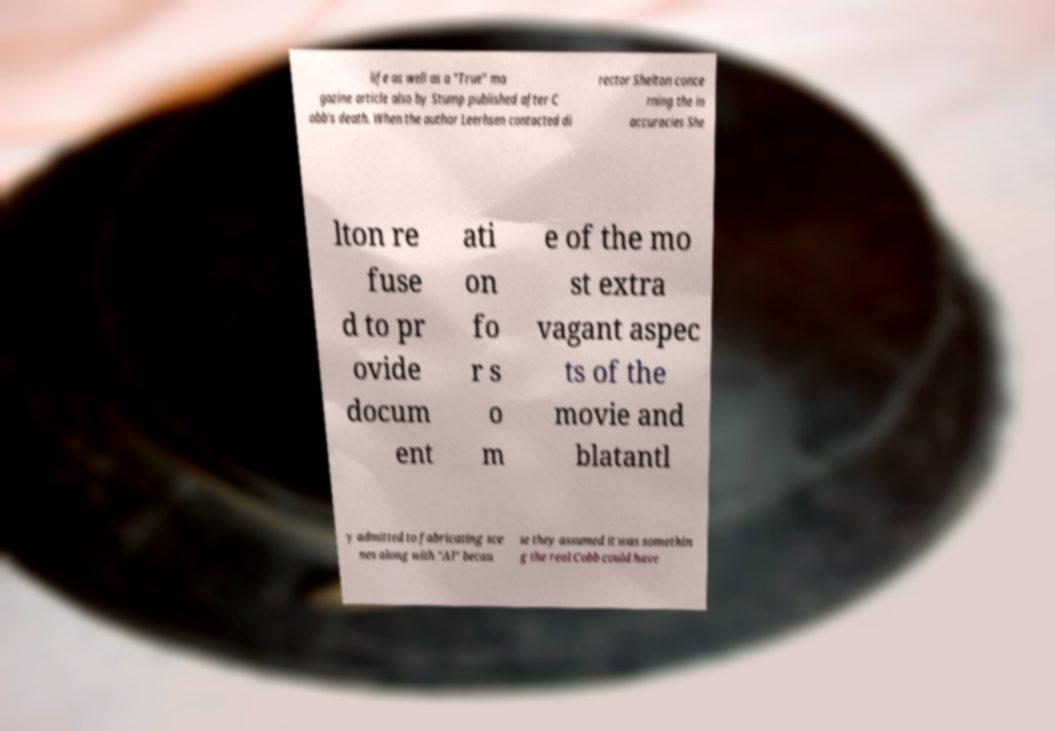Please read and relay the text visible in this image. What does it say? life as well as a "True" ma gazine article also by Stump published after C obb's death. When the author Leerhsen contacted di rector Shelton conce rning the in accuracies She lton re fuse d to pr ovide docum ent ati on fo r s o m e of the mo st extra vagant aspec ts of the movie and blatantl y admitted to fabricating sce nes along with "Al" becau se they assumed it was somethin g the real Cobb could have 